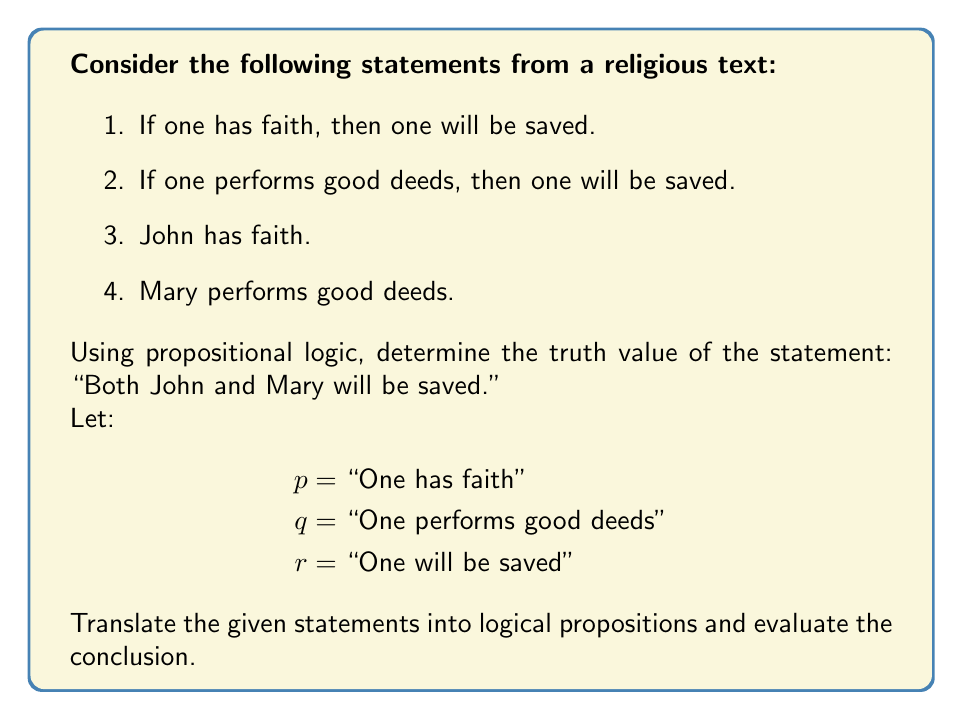Teach me how to tackle this problem. Let's approach this step-by-step using propositional logic:

1. Translate the statements into logical propositions:
   a. $p \rightarrow r$
   b. $q \rightarrow r$
   c. $p$ (for John)
   d. $q$ (for Mary)

2. We want to determine if both John and Mary will be saved. In logical terms, this is $(r_{\text{John}} \land r_{\text{Mary}})$.

3. For John:
   We have $p$ (John has faith) and $p \rightarrow r$.
   Using Modus Ponens, we can conclude $r_{\text{John}}$.

4. For Mary:
   We have $q$ (Mary performs good deeds) and $q \rightarrow r$.
   Using Modus Ponens, we can conclude $r_{\text{Mary}}$.

5. Since we have both $r_{\text{John}}$ and $r_{\text{Mary}}$, we can use the Conjunction rule:
   $r_{\text{John}} \land r_{\text{Mary}}$

6. This conjunction is true, which means the statement "Both John and Mary will be saved" is logically true based on the given premises.

It's important to note that this analysis is based solely on the logical structure of the given statements and does not consider theological interpretations or real-world implications.
Answer: True. Based on the given premises and using propositional logic, the statement "Both John and Mary will be saved" is logically true. 